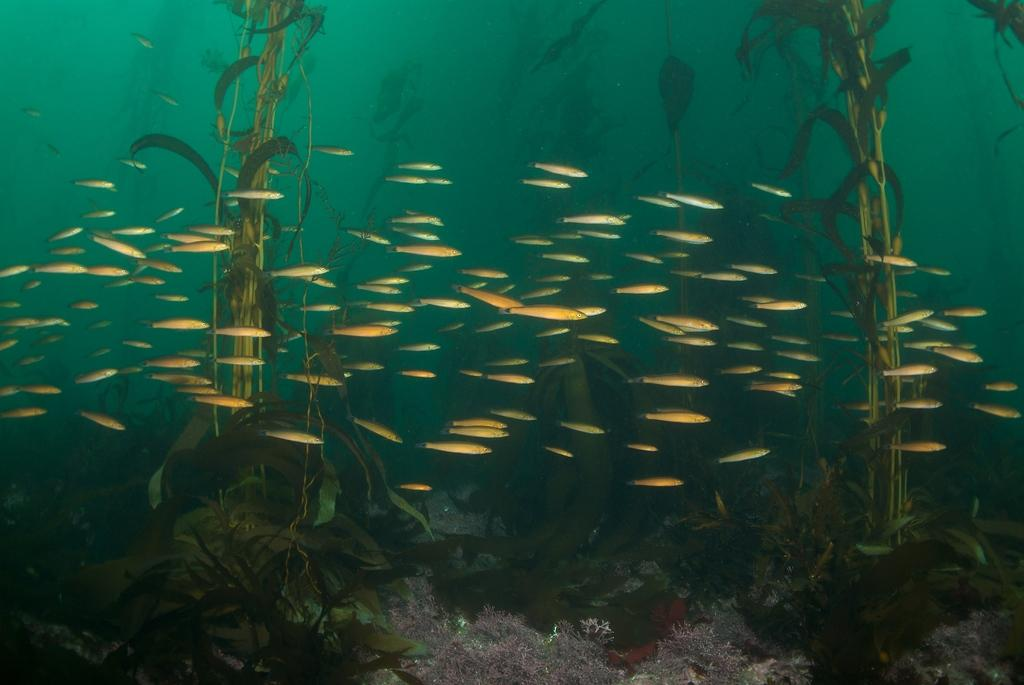What is the main subject of the image? The main subject of the image is water in the center. What can be found within the water? There are plants, fishes, and a few other objects in the water. Can you describe the plants in the water? The plants in the water are submerged and visible in the image. What type of animals are present in the water? There are fishes in the water. What is the title of the book seen in the image? There is no book present in the image; it features water with plants, fishes, and other objects. How many dimes are visible in the image? There are no dimes present in the image. 